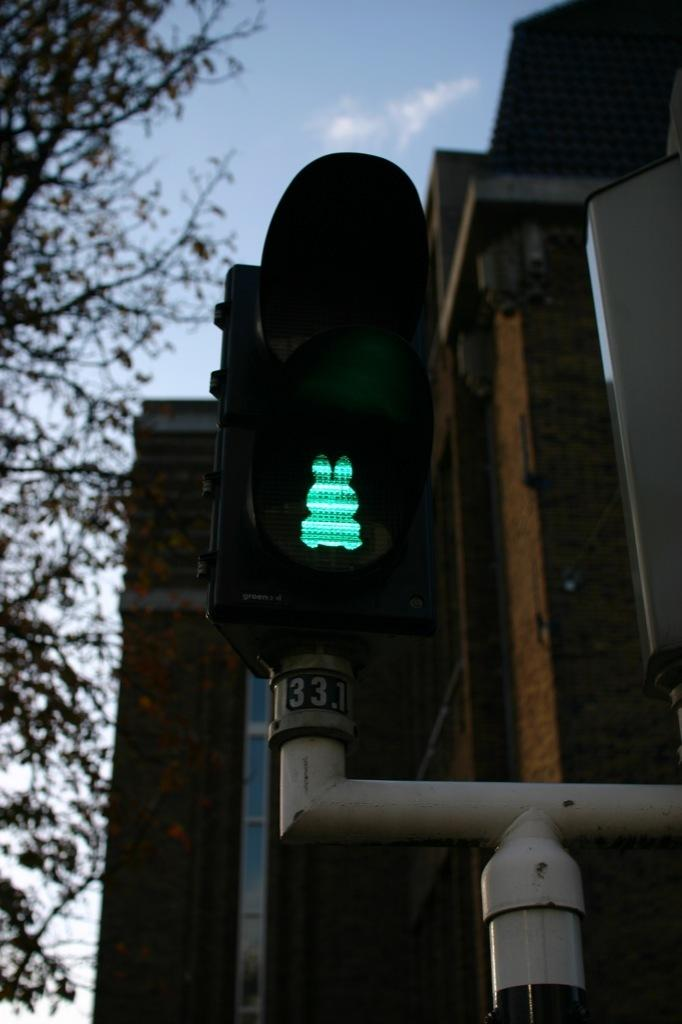What is the main object in the image? There is a traffic signal in the image. What color is the light on the traffic signal? The traffic signal has a green light. How is the traffic signal supported? The traffic signal is attached to a pole. What can be seen in the background of the image? There is a building in the background of the image. Where is the tree located in the image? There is a tree in the left corner of the image. What type of bulb is used in the oven in the image? There is no oven present in the image, so it is not possible to determine the type of bulb used. 